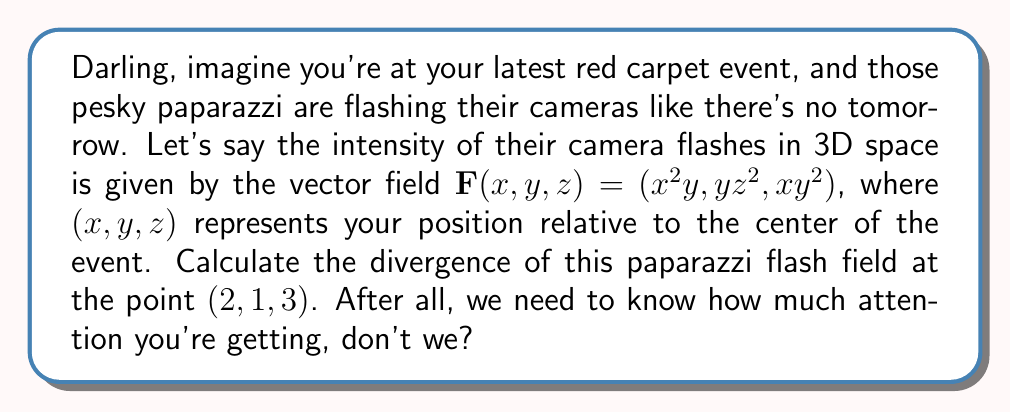Teach me how to tackle this problem. To compute the divergence of the vector field $\mathbf{F}(x,y,z) = (x^2y, yz^2, xy^2)$ at the point $(2,1,3)$, we'll follow these steps:

1) The divergence of a vector field $\mathbf{F}(x,y,z) = (F_1, F_2, F_3)$ is given by:

   $$\text{div}\mathbf{F} = \nabla \cdot \mathbf{F} = \frac{\partial F_1}{\partial x} + \frac{\partial F_2}{\partial y} + \frac{\partial F_3}{\partial z}$$

2) For our vector field:
   $F_1 = x^2y$
   $F_2 = yz^2$
   $F_3 = xy^2$

3) Let's calculate each partial derivative:

   $\frac{\partial F_1}{\partial x} = \frac{\partial}{\partial x}(x^2y) = 2xy$

   $\frac{\partial F_2}{\partial y} = \frac{\partial}{\partial y}(yz^2) = z^2$

   $\frac{\partial F_3}{\partial z} = \frac{\partial}{\partial z}(xy^2) = 0$

4) Now, we can write the divergence:

   $$\text{div}\mathbf{F} = 2xy + z^2 + 0 = 2xy + z^2$$

5) To evaluate this at the point $(2,1,3)$, we substitute $x=2$, $y=1$, and $z=3$:

   $$\text{div}\mathbf{F}(2,1,3) = 2(2)(1) + 3^2 = 4 + 9 = 13$$

Therefore, the divergence of the paparazzi flash field at the point $(2,1,3)$ is 13.
Answer: 13 